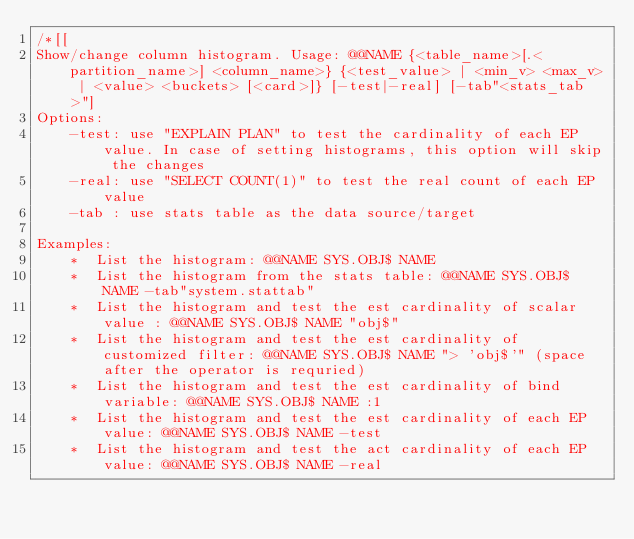Convert code to text. <code><loc_0><loc_0><loc_500><loc_500><_SQL_>/*[[
Show/change column histogram. Usage: @@NAME {<table_name>[.<partition_name>] <column_name>} {<test_value> | <min_v> <max_v> | <value> <buckets> [<card>]} [-test|-real] [-tab"<stats_tab>"]
Options:
    -test: use "EXPLAIN PLAN" to test the cardinality of each EP value. In case of setting histograms, this option will skip the changes
    -real: use "SELECT COUNT(1)" to test the real count of each EP value
    -tab : use stats table as the data source/target

Examples:
    *  List the histogram: @@NAME SYS.OBJ$ NAME
    *  List the histogram from the stats table: @@NAME SYS.OBJ$ NAME -tab"system.stattab"
    *  List the histogram and test the est cardinality of scalar value : @@NAME SYS.OBJ$ NAME "obj$"
    *  List the histogram and test the est cardinality of customized filter: @@NAME SYS.OBJ$ NAME "> 'obj$'" (space after the operator is requried)
    *  List the histogram and test the est cardinality of bind variable: @@NAME SYS.OBJ$ NAME :1
    *  List the histogram and test the est cardinality of each EP value: @@NAME SYS.OBJ$ NAME -test
    *  List the histogram and test the act cardinality of each EP value: @@NAME SYS.OBJ$ NAME -real</code> 